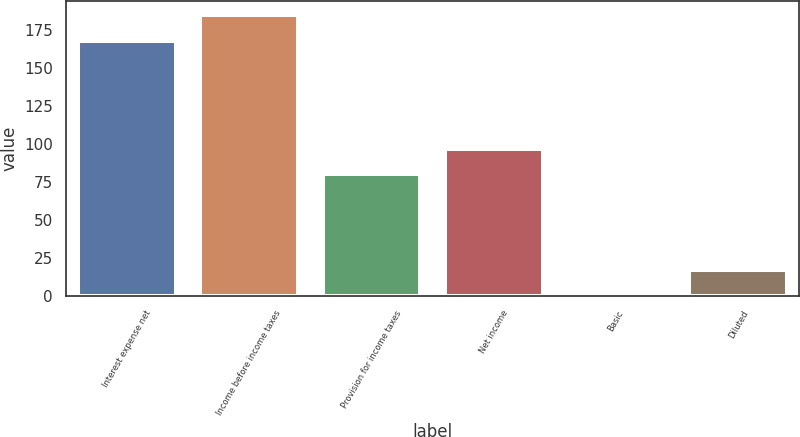Convert chart to OTSL. <chart><loc_0><loc_0><loc_500><loc_500><bar_chart><fcel>Interest expense net<fcel>Income before income taxes<fcel>Provision for income taxes<fcel>Net income<fcel>Basic<fcel>Diluted<nl><fcel>168<fcel>184.79<fcel>80<fcel>96.79<fcel>0.07<fcel>16.86<nl></chart> 